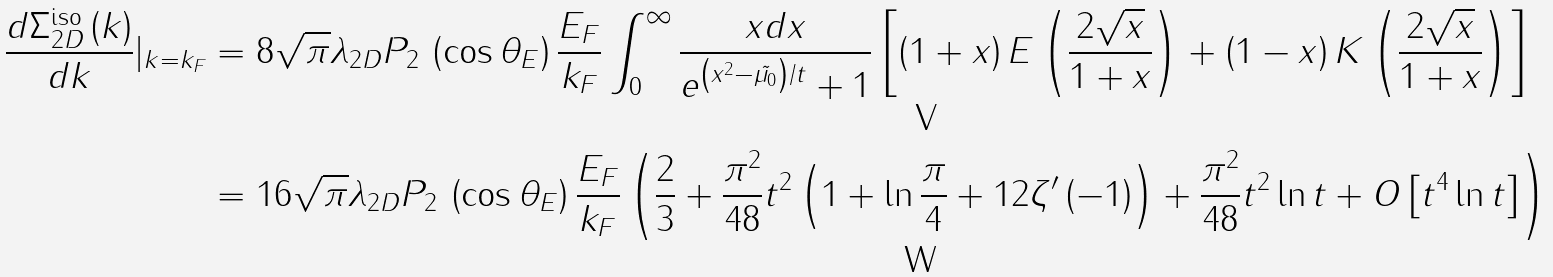<formula> <loc_0><loc_0><loc_500><loc_500>\frac { d \Sigma _ { 2 D } ^ { \text {iso} } \left ( k \right ) } { d k } | _ { k = k _ { F } } & = 8 \sqrt { \pi } \lambda _ { 2 D } P _ { 2 } \, \left ( \cos \theta _ { E } \right ) \frac { E _ { F } } { k _ { F } } \int _ { 0 } ^ { \infty } \frac { x d x } { e ^ { \left ( x ^ { 2 } - \tilde { \mu _ { 0 } } \right ) / t } + 1 } \left [ \left ( 1 + x \right ) E \left ( \frac { 2 \sqrt { x } } { 1 + x } \right ) + \left ( 1 - x \right ) K \left ( \frac { 2 \sqrt { x } } { 1 + x } \right ) \right ] \\ & = 1 6 \sqrt { \pi } \lambda _ { 2 D } P _ { 2 } \, \left ( \cos \theta _ { E } \right ) \frac { E _ { F } } { k _ { F } } \left ( \frac { 2 } { 3 } + \frac { \pi ^ { 2 } } { 4 8 } t ^ { 2 } \left ( 1 + \ln \frac { \pi } { 4 } + 1 2 \zeta ^ { \prime } \left ( - 1 \right ) \right ) + \frac { \pi ^ { 2 } } { 4 8 } t ^ { 2 } \ln t + O \left [ t ^ { 4 } \ln t \right ] \right )</formula> 